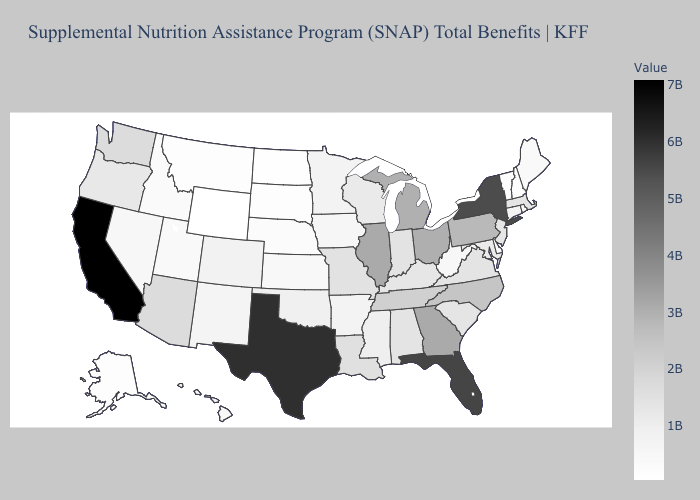Does Nebraska have the highest value in the MidWest?
Concise answer only. No. Does Vermont have the highest value in the Northeast?
Give a very brief answer. No. Does Virginia have the lowest value in the South?
Quick response, please. No. Which states have the lowest value in the Northeast?
Quick response, please. Vermont. Does Louisiana have a lower value than North Dakota?
Give a very brief answer. No. 